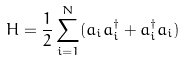Convert formula to latex. <formula><loc_0><loc_0><loc_500><loc_500>H = { \frac { 1 } { 2 } } \sum _ { i = 1 } ^ { N } ( a _ { i } a _ { i } ^ { \dagger } + a _ { i } ^ { \dagger } a _ { i } )</formula> 